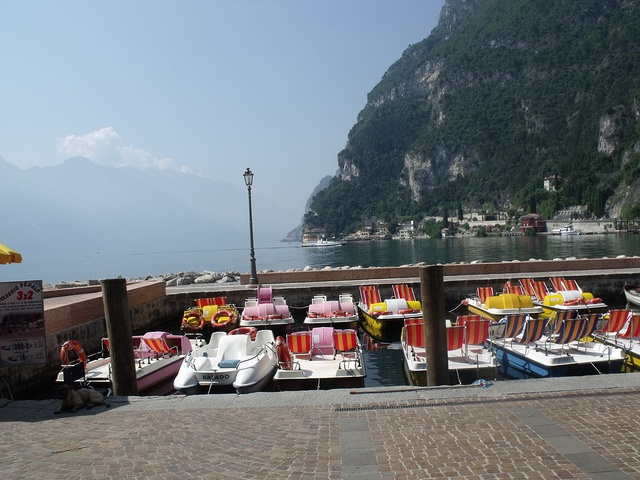Describe the objects in this image and their specific colors. I can see boat in lightblue, black, white, gray, and darkgray tones, chair in lightblue, brown, black, and gray tones, boat in lightblue, black, darkgray, gray, and maroon tones, boat in lightblue, black, lightgray, darkgray, and gray tones, and boat in lightblue, black, lightgray, gray, and brown tones in this image. 